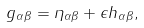<formula> <loc_0><loc_0><loc_500><loc_500>g _ { \alpha \beta } = \eta _ { \alpha \beta } + \epsilon h _ { \alpha \beta } ,</formula> 